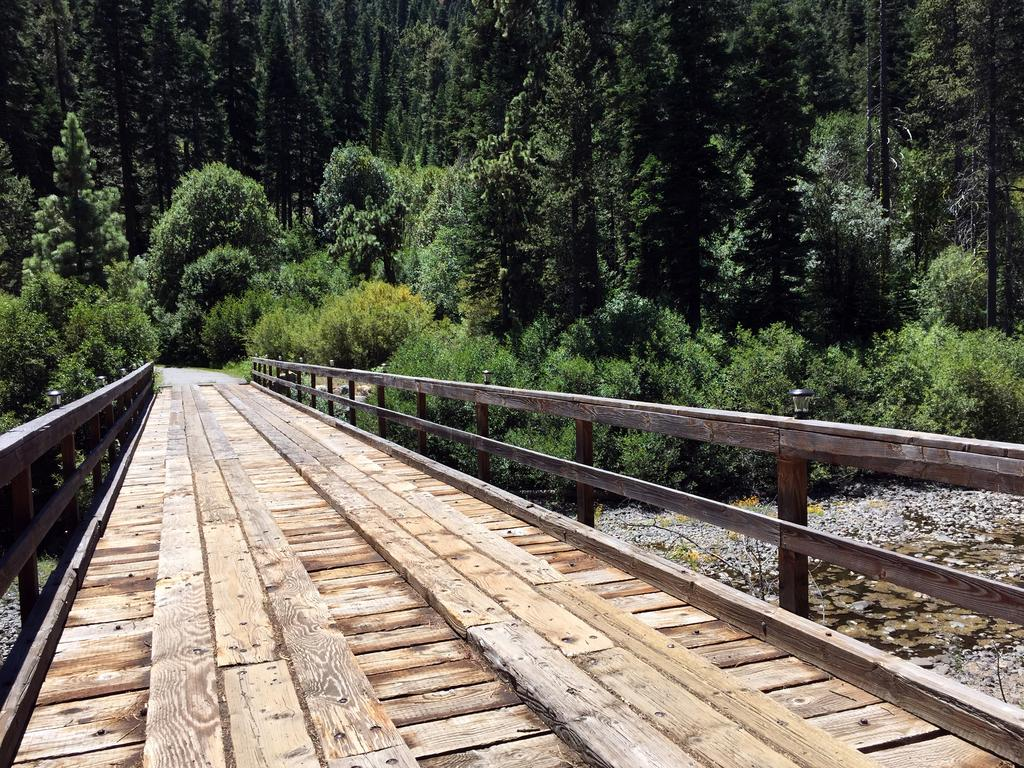What structure is the main focus of the image? There is a bridge in the image. What other elements can be seen in the image besides the bridge? There are plants visible in the image. What can be seen in the background of the image? There are trees in the background of the image. What type of government is depicted in the image? There is no depiction of a government in the image; it features a bridge, plants, and trees. What color is the collar on the tree in the image? There are no collars present on the trees in the image, as trees do not have collars. 